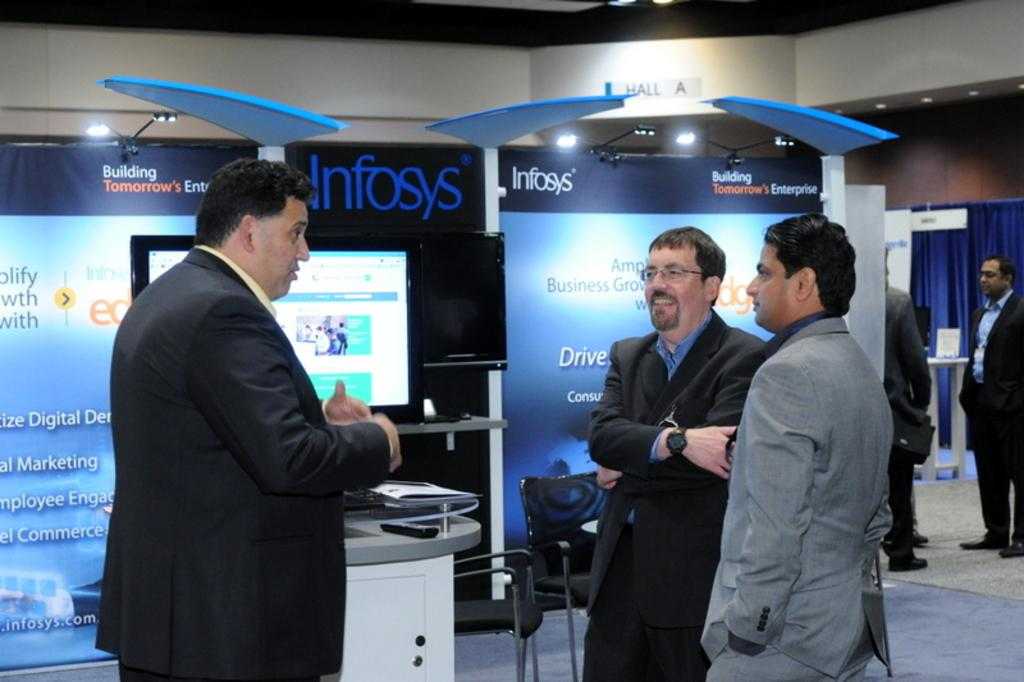What can be seen in the image involving people? There are people standing in the image. What type of signage is present in the image? There are banners in the image. What type of furniture is visible in the image? Chairs and tables are visible in the image. What type of display devices are in the image? Screens are in the image. What type of information boards are present in the image? Boards are in the image. What type of window treatment is in the image? Blue curtains are in the image. What type of structure is in the image? There is a building in the image. What type of lighting is visible in the image? Lights are visible in the image. How many bikes are parked near the building in the image? There are no bikes present in the image. Where is the faucet located in the image? There is no faucet present in the image. What type of books is in the image? There is no library present in the image. 